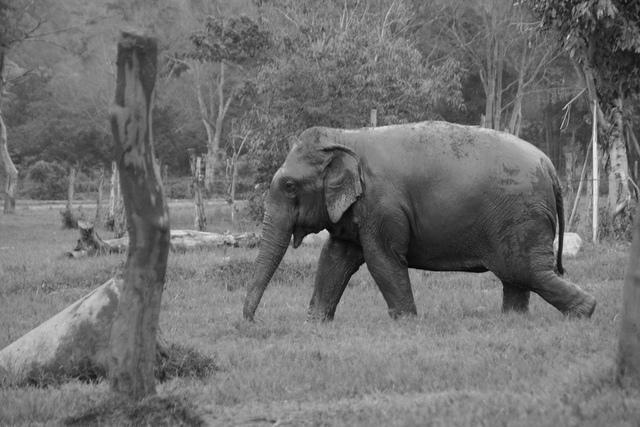How many chopped tree trunks are shown in front of the elephant?
Give a very brief answer. 1. How many tusks does the elephant have?
Give a very brief answer. 0. How many elephants are there?
Give a very brief answer. 1. How many people are typing computer?
Give a very brief answer. 0. 